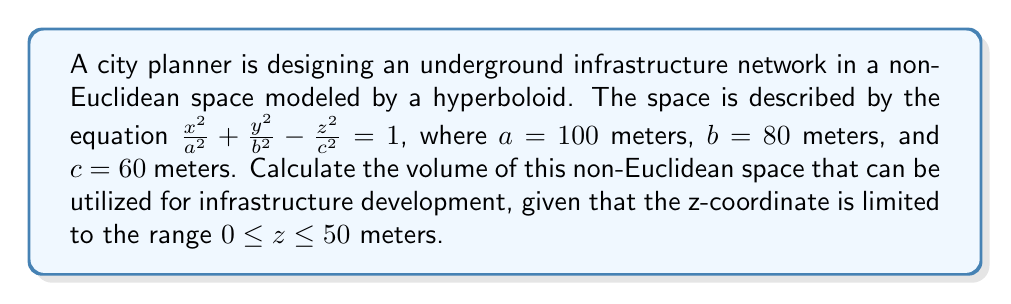Solve this math problem. To calculate the volume of the hyperboloid of one sheet within the given z-range, we'll follow these steps:

1) The volume of a hyperboloid of one sheet is given by the formula:

   $$V = \frac{4\pi abc}{3}$$

2) However, this formula gives the volume for the entire hyperboloid. We need to find the volume of a portion of it.

3) To do this, we'll use the formula for the volume of a solid of revolution:

   $$V = \pi \int_{z_1}^{z_2} [x(z)^2 + y(z)^2] dz$$

4) From the equation of the hyperboloid, we can express x and y in terms of z:

   $$x^2 = a^2(1 + \frac{z^2}{c^2}) \quad \text{and} \quad y^2 = b^2(1 + \frac{z^2}{c^2})$$

5) Substituting these into our volume formula:

   $$V = \pi \int_{0}^{50} [a^2(1 + \frac{z^2}{c^2}) + b^2(1 + \frac{z^2}{c^2})] dz$$

6) Simplifying:

   $$V = \pi(a^2 + b^2) \int_{0}^{50} (1 + \frac{z^2}{c^2}) dz$$

7) Evaluating the integral:

   $$V = \pi(a^2 + b^2) [z + \frac{z^3}{3c^2}]_{0}^{50}$$

8) Substituting the values:

   $$V = \pi(100^2 + 80^2) [50 + \frac{50^3}{3(60^2)}]$$

9) Calculating:

   $$V \approx 1,396,263.89 \text{ cubic meters}$$
Answer: $1,396,263.89 \text{ m}^3$ 